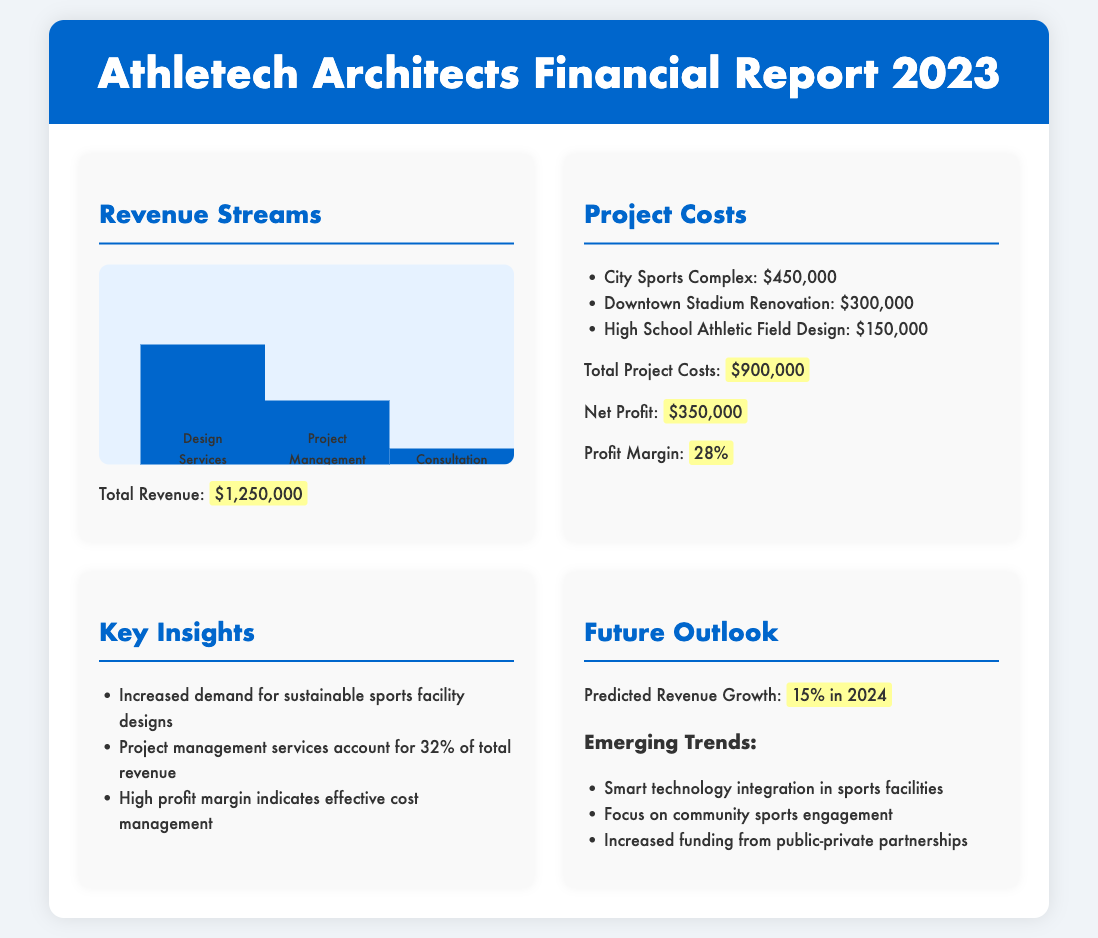what is the total revenue? The total revenue is stated in the document as $1,250,000.
Answer: $1,250,000 what percentage of total revenue comes from design services? The document indicates that design services account for 60% of total revenue.
Answer: 60% what is the total project cost? The total project costs are provided as $900,000.
Answer: $900,000 what is the profit margin? The profit margin is explicitly mentioned in the document as 28%.
Answer: 28% which project had the highest cost? The highest cost project listed is the City Sports Complex, costing $450,000.
Answer: City Sports Complex what is the predicted revenue growth for 2024? The predicted revenue growth for 2024 is stated as 15%.
Answer: 15% how much revenue generates from project management services? Project management services account for 32% of total revenue, which equals $400,000.
Answer: $400,000 what key insight is provided about project management services? The document highlights that project management services account for 32% of total revenue.
Answer: 32% what emerging trend involves technology in sports facilities? The document mentions smart technology integration in sports facilities as an emerging trend.
Answer: Smart technology integration what does the document suggest about sustainable sports facility designs? The document notes an increased demand for sustainable sports facility designs.
Answer: Increased demand 